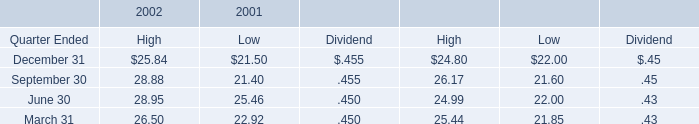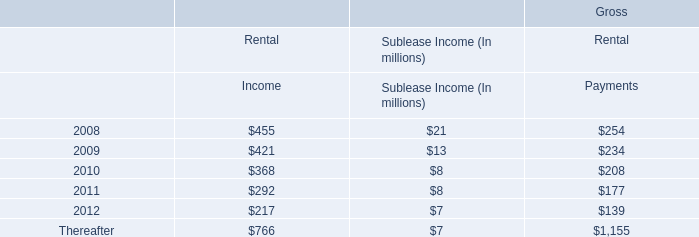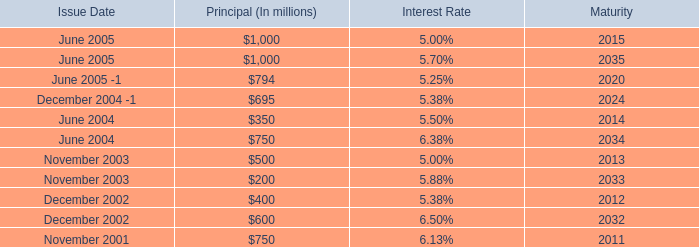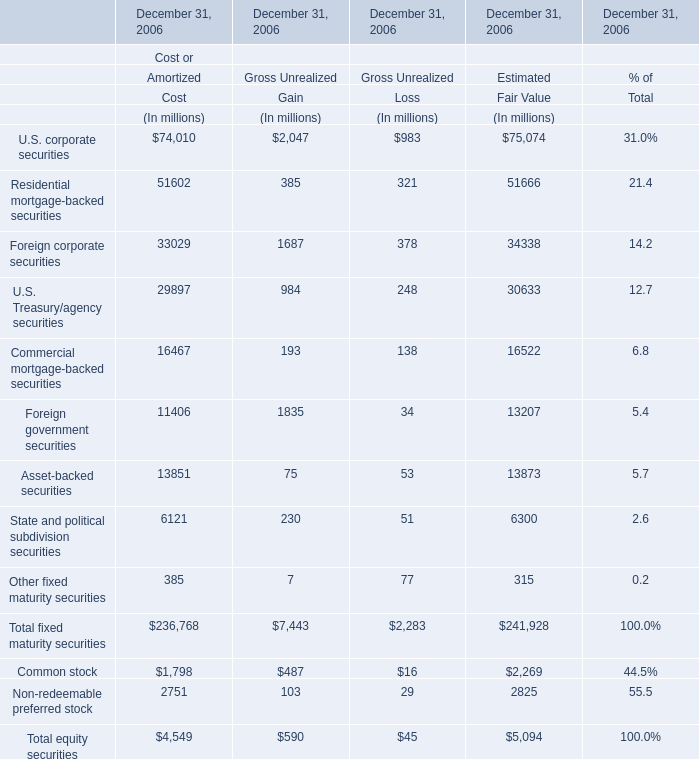What do all U.S. corporate securities sum up without those U.S. corporate securities smaller than1000 in 2006? (in million) 
Computations: ((74010 + 2047) + 75074)
Answer: 151131.0. 